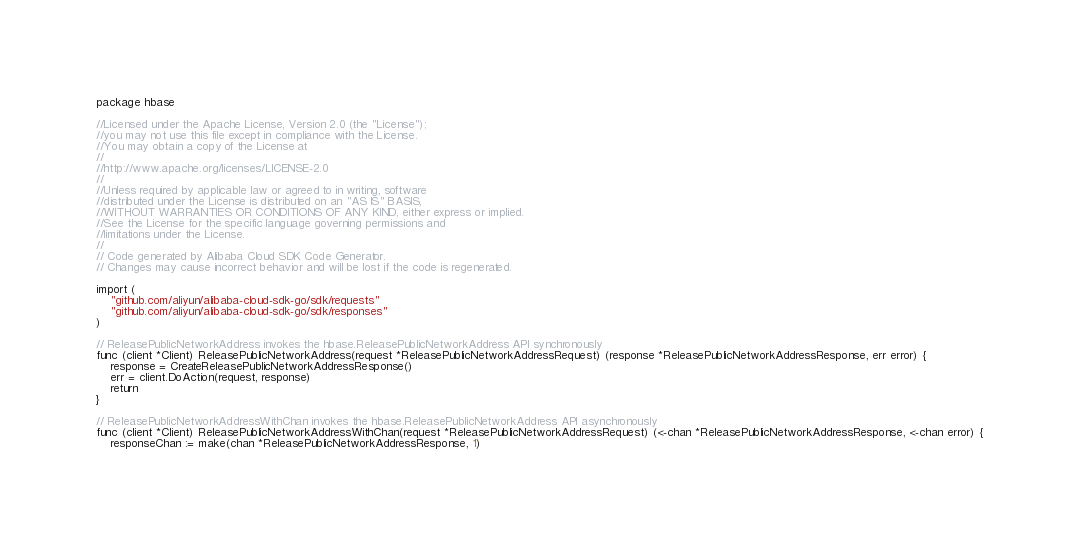Convert code to text. <code><loc_0><loc_0><loc_500><loc_500><_Go_>package hbase

//Licensed under the Apache License, Version 2.0 (the "License");
//you may not use this file except in compliance with the License.
//You may obtain a copy of the License at
//
//http://www.apache.org/licenses/LICENSE-2.0
//
//Unless required by applicable law or agreed to in writing, software
//distributed under the License is distributed on an "AS IS" BASIS,
//WITHOUT WARRANTIES OR CONDITIONS OF ANY KIND, either express or implied.
//See the License for the specific language governing permissions and
//limitations under the License.
//
// Code generated by Alibaba Cloud SDK Code Generator.
// Changes may cause incorrect behavior and will be lost if the code is regenerated.

import (
	"github.com/aliyun/alibaba-cloud-sdk-go/sdk/requests"
	"github.com/aliyun/alibaba-cloud-sdk-go/sdk/responses"
)

// ReleasePublicNetworkAddress invokes the hbase.ReleasePublicNetworkAddress API synchronously
func (client *Client) ReleasePublicNetworkAddress(request *ReleasePublicNetworkAddressRequest) (response *ReleasePublicNetworkAddressResponse, err error) {
	response = CreateReleasePublicNetworkAddressResponse()
	err = client.DoAction(request, response)
	return
}

// ReleasePublicNetworkAddressWithChan invokes the hbase.ReleasePublicNetworkAddress API asynchronously
func (client *Client) ReleasePublicNetworkAddressWithChan(request *ReleasePublicNetworkAddressRequest) (<-chan *ReleasePublicNetworkAddressResponse, <-chan error) {
	responseChan := make(chan *ReleasePublicNetworkAddressResponse, 1)</code> 